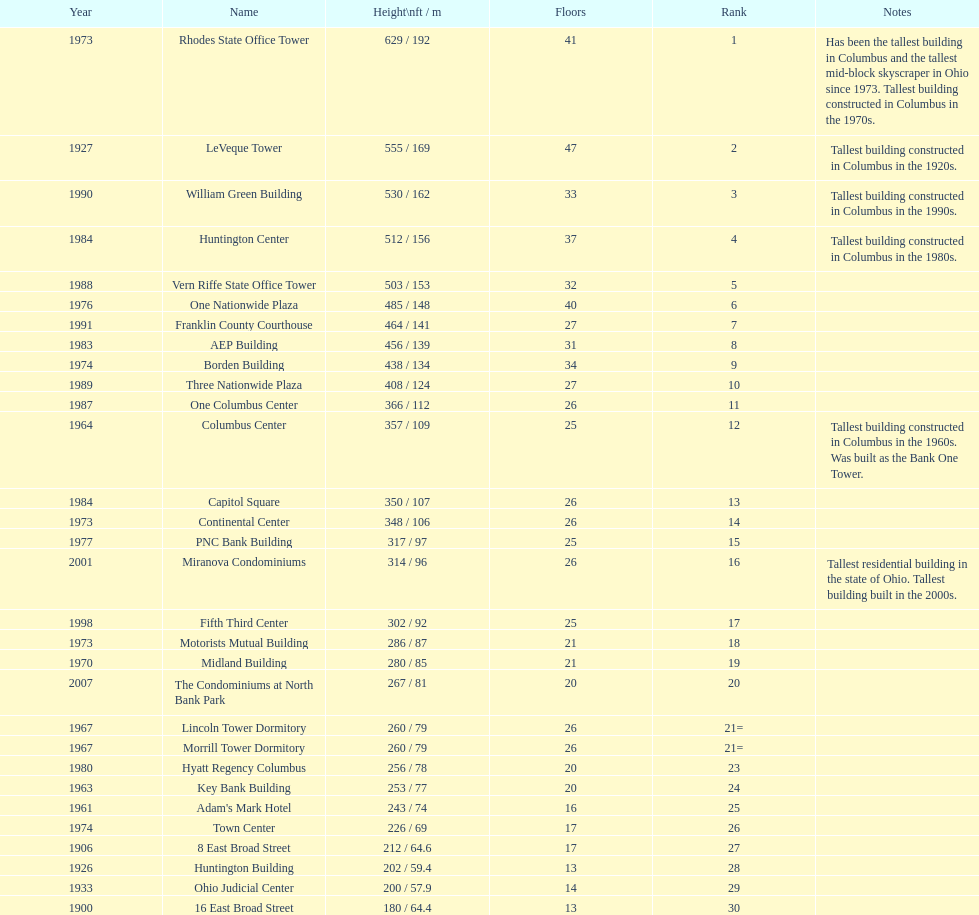What is the tallest building in columbus? Rhodes State Office Tower. Help me parse the entirety of this table. {'header': ['Year', 'Name', 'Height\\nft / m', 'Floors', 'Rank', 'Notes'], 'rows': [['1973', 'Rhodes State Office Tower', '629 / 192', '41', '1', 'Has been the tallest building in Columbus and the tallest mid-block skyscraper in Ohio since 1973. Tallest building constructed in Columbus in the 1970s.'], ['1927', 'LeVeque Tower', '555 / 169', '47', '2', 'Tallest building constructed in Columbus in the 1920s.'], ['1990', 'William Green Building', '530 / 162', '33', '3', 'Tallest building constructed in Columbus in the 1990s.'], ['1984', 'Huntington Center', '512 / 156', '37', '4', 'Tallest building constructed in Columbus in the 1980s.'], ['1988', 'Vern Riffe State Office Tower', '503 / 153', '32', '5', ''], ['1976', 'One Nationwide Plaza', '485 / 148', '40', '6', ''], ['1991', 'Franklin County Courthouse', '464 / 141', '27', '7', ''], ['1983', 'AEP Building', '456 / 139', '31', '8', ''], ['1974', 'Borden Building', '438 / 134', '34', '9', ''], ['1989', 'Three Nationwide Plaza', '408 / 124', '27', '10', ''], ['1987', 'One Columbus Center', '366 / 112', '26', '11', ''], ['1964', 'Columbus Center', '357 / 109', '25', '12', 'Tallest building constructed in Columbus in the 1960s. Was built as the Bank One Tower.'], ['1984', 'Capitol Square', '350 / 107', '26', '13', ''], ['1973', 'Continental Center', '348 / 106', '26', '14', ''], ['1977', 'PNC Bank Building', '317 / 97', '25', '15', ''], ['2001', 'Miranova Condominiums', '314 / 96', '26', '16', 'Tallest residential building in the state of Ohio. Tallest building built in the 2000s.'], ['1998', 'Fifth Third Center', '302 / 92', '25', '17', ''], ['1973', 'Motorists Mutual Building', '286 / 87', '21', '18', ''], ['1970', 'Midland Building', '280 / 85', '21', '19', ''], ['2007', 'The Condominiums at North Bank Park', '267 / 81', '20', '20', ''], ['1967', 'Lincoln Tower Dormitory', '260 / 79', '26', '21=', ''], ['1967', 'Morrill Tower Dormitory', '260 / 79', '26', '21=', ''], ['1980', 'Hyatt Regency Columbus', '256 / 78', '20', '23', ''], ['1963', 'Key Bank Building', '253 / 77', '20', '24', ''], ['1961', "Adam's Mark Hotel", '243 / 74', '16', '25', ''], ['1974', 'Town Center', '226 / 69', '17', '26', ''], ['1906', '8 East Broad Street', '212 / 64.6', '17', '27', ''], ['1926', 'Huntington Building', '202 / 59.4', '13', '28', ''], ['1933', 'Ohio Judicial Center', '200 / 57.9', '14', '29', ''], ['1900', '16 East Broad Street', '180 / 64.4', '13', '30', '']]} 